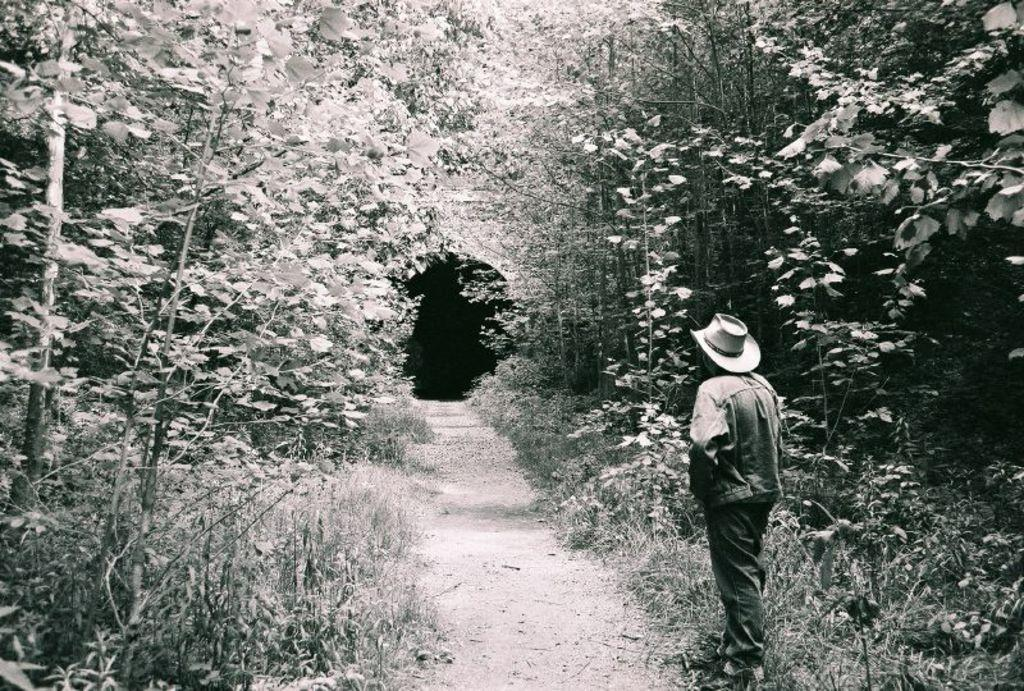What is the main subject of the image? There is a person standing in the image. Can you describe the person's attire? The person is wearing clothes and a hat. What type of natural environment is visible in the image? There are trees and grass visible in the image. What type of structure can be seen in the image? There is an arch construction in the image. Is there a path visible in the image? Yes, there is a path in the image. How many sheep can be seen grazing on the grass in the image? There are no sheep present in the image; it features a person standing, trees, grass, an arch construction, and a path. What type of sea creature can be seen swimming near the arch construction in the image? There are no sea creatures present in the image, as it is set in a land-based environment with trees, grass, and a path. 